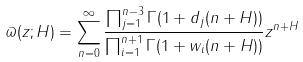<formula> <loc_0><loc_0><loc_500><loc_500>\varpi ( z ; H ) = \sum _ { n = 0 } ^ { \infty } \frac { \prod _ { j = 1 } ^ { n - 3 } \Gamma ( 1 + d _ { j } ( n + H ) ) } { \prod _ { i = 1 } ^ { n + 1 } \Gamma ( 1 + w _ { i } ( n + H ) ) } z ^ { n + H }</formula> 